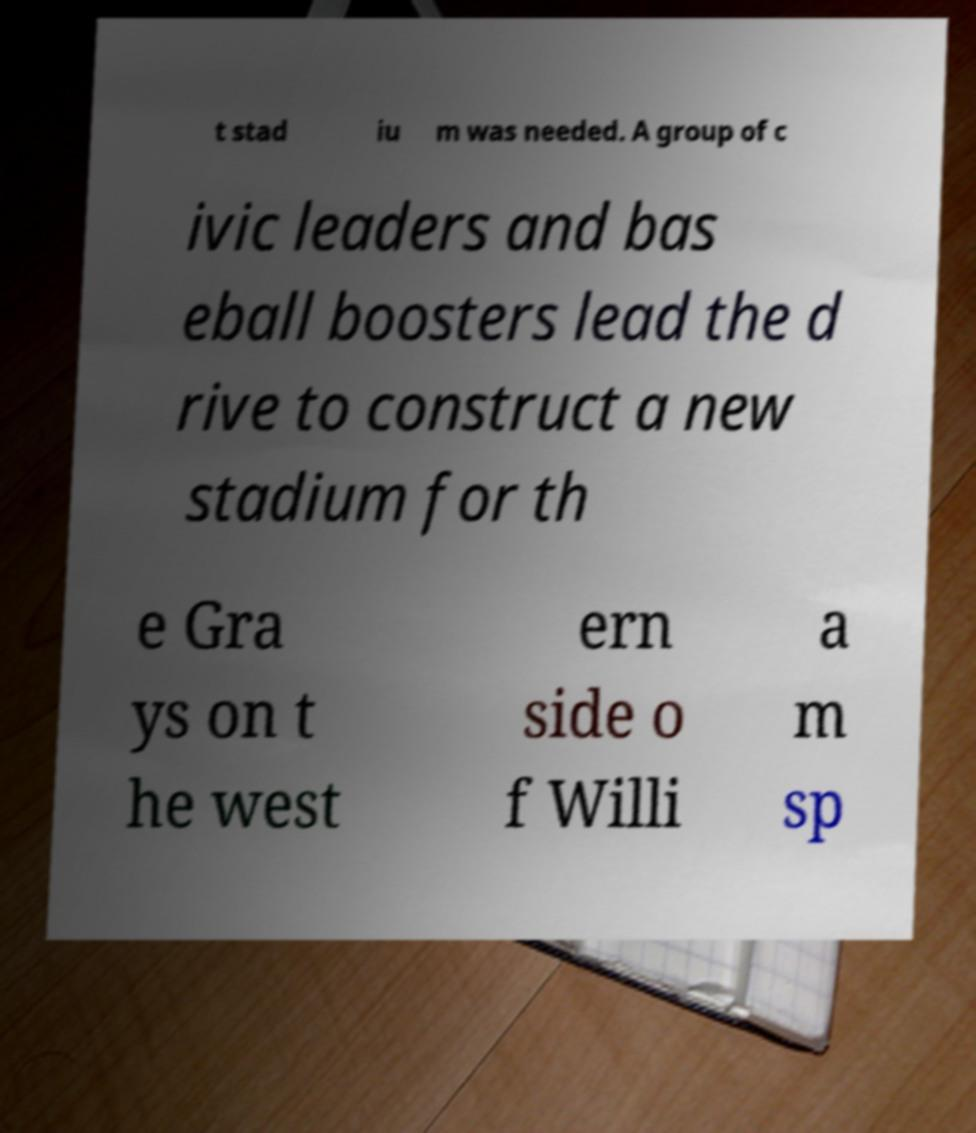For documentation purposes, I need the text within this image transcribed. Could you provide that? t stad iu m was needed. A group of c ivic leaders and bas eball boosters lead the d rive to construct a new stadium for th e Gra ys on t he west ern side o f Willi a m sp 